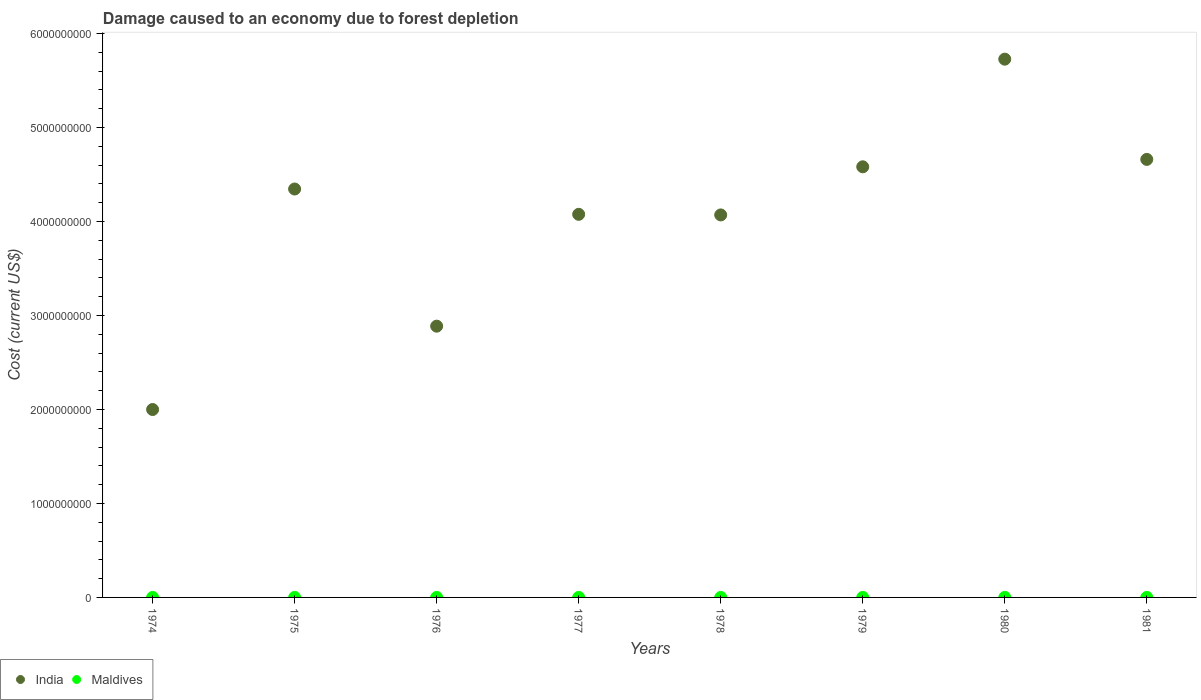How many different coloured dotlines are there?
Give a very brief answer. 2. Is the number of dotlines equal to the number of legend labels?
Provide a short and direct response. Yes. What is the cost of damage caused due to forest depletion in India in 1974?
Your response must be concise. 2.00e+09. Across all years, what is the maximum cost of damage caused due to forest depletion in India?
Your response must be concise. 5.73e+09. Across all years, what is the minimum cost of damage caused due to forest depletion in Maldives?
Provide a succinct answer. 7.74e+04. In which year was the cost of damage caused due to forest depletion in Maldives minimum?
Offer a very short reply. 1974. What is the total cost of damage caused due to forest depletion in India in the graph?
Keep it short and to the point. 3.23e+1. What is the difference between the cost of damage caused due to forest depletion in Maldives in 1974 and that in 1978?
Your response must be concise. -8.65e+04. What is the difference between the cost of damage caused due to forest depletion in India in 1979 and the cost of damage caused due to forest depletion in Maldives in 1980?
Your response must be concise. 4.58e+09. What is the average cost of damage caused due to forest depletion in Maldives per year?
Offer a very short reply. 1.62e+05. In the year 1980, what is the difference between the cost of damage caused due to forest depletion in Maldives and cost of damage caused due to forest depletion in India?
Provide a short and direct response. -5.73e+09. In how many years, is the cost of damage caused due to forest depletion in India greater than 4000000000 US$?
Make the answer very short. 6. What is the ratio of the cost of damage caused due to forest depletion in Maldives in 1975 to that in 1977?
Offer a terse response. 1.21. Is the difference between the cost of damage caused due to forest depletion in Maldives in 1977 and 1979 greater than the difference between the cost of damage caused due to forest depletion in India in 1977 and 1979?
Provide a succinct answer. Yes. What is the difference between the highest and the second highest cost of damage caused due to forest depletion in India?
Your answer should be compact. 1.07e+09. What is the difference between the highest and the lowest cost of damage caused due to forest depletion in Maldives?
Give a very brief answer. 1.46e+05. Is the sum of the cost of damage caused due to forest depletion in India in 1979 and 1980 greater than the maximum cost of damage caused due to forest depletion in Maldives across all years?
Offer a terse response. Yes. What is the difference between two consecutive major ticks on the Y-axis?
Provide a short and direct response. 1.00e+09. Are the values on the major ticks of Y-axis written in scientific E-notation?
Ensure brevity in your answer.  No. Does the graph contain any zero values?
Offer a very short reply. No. How many legend labels are there?
Make the answer very short. 2. How are the legend labels stacked?
Your answer should be compact. Horizontal. What is the title of the graph?
Give a very brief answer. Damage caused to an economy due to forest depletion. Does "Estonia" appear as one of the legend labels in the graph?
Your answer should be very brief. No. What is the label or title of the Y-axis?
Provide a short and direct response. Cost (current US$). What is the Cost (current US$) of India in 1974?
Ensure brevity in your answer.  2.00e+09. What is the Cost (current US$) in Maldives in 1974?
Provide a succinct answer. 7.74e+04. What is the Cost (current US$) of India in 1975?
Your answer should be very brief. 4.35e+09. What is the Cost (current US$) in Maldives in 1975?
Give a very brief answer. 1.96e+05. What is the Cost (current US$) in India in 1976?
Offer a very short reply. 2.89e+09. What is the Cost (current US$) of Maldives in 1976?
Provide a succinct answer. 1.11e+05. What is the Cost (current US$) of India in 1977?
Provide a succinct answer. 4.08e+09. What is the Cost (current US$) in Maldives in 1977?
Make the answer very short. 1.63e+05. What is the Cost (current US$) of India in 1978?
Ensure brevity in your answer.  4.07e+09. What is the Cost (current US$) of Maldives in 1978?
Ensure brevity in your answer.  1.64e+05. What is the Cost (current US$) in India in 1979?
Your answer should be very brief. 4.58e+09. What is the Cost (current US$) of Maldives in 1979?
Offer a very short reply. 1.77e+05. What is the Cost (current US$) in India in 1980?
Give a very brief answer. 5.73e+09. What is the Cost (current US$) in Maldives in 1980?
Give a very brief answer. 2.24e+05. What is the Cost (current US$) of India in 1981?
Provide a short and direct response. 4.66e+09. What is the Cost (current US$) in Maldives in 1981?
Offer a terse response. 1.82e+05. Across all years, what is the maximum Cost (current US$) of India?
Give a very brief answer. 5.73e+09. Across all years, what is the maximum Cost (current US$) of Maldives?
Offer a very short reply. 2.24e+05. Across all years, what is the minimum Cost (current US$) of India?
Your answer should be very brief. 2.00e+09. Across all years, what is the minimum Cost (current US$) of Maldives?
Give a very brief answer. 7.74e+04. What is the total Cost (current US$) in India in the graph?
Give a very brief answer. 3.23e+1. What is the total Cost (current US$) of Maldives in the graph?
Your response must be concise. 1.30e+06. What is the difference between the Cost (current US$) of India in 1974 and that in 1975?
Offer a terse response. -2.35e+09. What is the difference between the Cost (current US$) of Maldives in 1974 and that in 1975?
Give a very brief answer. -1.19e+05. What is the difference between the Cost (current US$) of India in 1974 and that in 1976?
Offer a very short reply. -8.87e+08. What is the difference between the Cost (current US$) in Maldives in 1974 and that in 1976?
Your answer should be compact. -3.35e+04. What is the difference between the Cost (current US$) of India in 1974 and that in 1977?
Offer a terse response. -2.08e+09. What is the difference between the Cost (current US$) of Maldives in 1974 and that in 1977?
Ensure brevity in your answer.  -8.54e+04. What is the difference between the Cost (current US$) in India in 1974 and that in 1978?
Provide a succinct answer. -2.07e+09. What is the difference between the Cost (current US$) of Maldives in 1974 and that in 1978?
Give a very brief answer. -8.65e+04. What is the difference between the Cost (current US$) of India in 1974 and that in 1979?
Your response must be concise. -2.58e+09. What is the difference between the Cost (current US$) of Maldives in 1974 and that in 1979?
Your response must be concise. -1.00e+05. What is the difference between the Cost (current US$) of India in 1974 and that in 1980?
Provide a succinct answer. -3.73e+09. What is the difference between the Cost (current US$) in Maldives in 1974 and that in 1980?
Offer a terse response. -1.46e+05. What is the difference between the Cost (current US$) in India in 1974 and that in 1981?
Give a very brief answer. -2.66e+09. What is the difference between the Cost (current US$) in Maldives in 1974 and that in 1981?
Your response must be concise. -1.05e+05. What is the difference between the Cost (current US$) in India in 1975 and that in 1976?
Your answer should be compact. 1.46e+09. What is the difference between the Cost (current US$) of Maldives in 1975 and that in 1976?
Provide a succinct answer. 8.53e+04. What is the difference between the Cost (current US$) of India in 1975 and that in 1977?
Ensure brevity in your answer.  2.69e+08. What is the difference between the Cost (current US$) of Maldives in 1975 and that in 1977?
Make the answer very short. 3.34e+04. What is the difference between the Cost (current US$) in India in 1975 and that in 1978?
Keep it short and to the point. 2.76e+08. What is the difference between the Cost (current US$) in Maldives in 1975 and that in 1978?
Make the answer very short. 3.24e+04. What is the difference between the Cost (current US$) of India in 1975 and that in 1979?
Your answer should be compact. -2.36e+08. What is the difference between the Cost (current US$) in Maldives in 1975 and that in 1979?
Make the answer very short. 1.88e+04. What is the difference between the Cost (current US$) of India in 1975 and that in 1980?
Offer a terse response. -1.38e+09. What is the difference between the Cost (current US$) in Maldives in 1975 and that in 1980?
Keep it short and to the point. -2.76e+04. What is the difference between the Cost (current US$) of India in 1975 and that in 1981?
Offer a terse response. -3.15e+08. What is the difference between the Cost (current US$) in Maldives in 1975 and that in 1981?
Ensure brevity in your answer.  1.38e+04. What is the difference between the Cost (current US$) of India in 1976 and that in 1977?
Keep it short and to the point. -1.19e+09. What is the difference between the Cost (current US$) in Maldives in 1976 and that in 1977?
Give a very brief answer. -5.19e+04. What is the difference between the Cost (current US$) of India in 1976 and that in 1978?
Provide a short and direct response. -1.18e+09. What is the difference between the Cost (current US$) in Maldives in 1976 and that in 1978?
Offer a very short reply. -5.29e+04. What is the difference between the Cost (current US$) of India in 1976 and that in 1979?
Your answer should be very brief. -1.70e+09. What is the difference between the Cost (current US$) in Maldives in 1976 and that in 1979?
Your response must be concise. -6.65e+04. What is the difference between the Cost (current US$) of India in 1976 and that in 1980?
Provide a succinct answer. -2.84e+09. What is the difference between the Cost (current US$) in Maldives in 1976 and that in 1980?
Make the answer very short. -1.13e+05. What is the difference between the Cost (current US$) in India in 1976 and that in 1981?
Your answer should be very brief. -1.77e+09. What is the difference between the Cost (current US$) of Maldives in 1976 and that in 1981?
Keep it short and to the point. -7.15e+04. What is the difference between the Cost (current US$) of India in 1977 and that in 1978?
Offer a very short reply. 6.45e+06. What is the difference between the Cost (current US$) in Maldives in 1977 and that in 1978?
Your answer should be compact. -1039.7. What is the difference between the Cost (current US$) of India in 1977 and that in 1979?
Your answer should be compact. -5.06e+08. What is the difference between the Cost (current US$) of Maldives in 1977 and that in 1979?
Offer a terse response. -1.46e+04. What is the difference between the Cost (current US$) in India in 1977 and that in 1980?
Offer a terse response. -1.65e+09. What is the difference between the Cost (current US$) in Maldives in 1977 and that in 1980?
Provide a succinct answer. -6.10e+04. What is the difference between the Cost (current US$) in India in 1977 and that in 1981?
Give a very brief answer. -5.84e+08. What is the difference between the Cost (current US$) in Maldives in 1977 and that in 1981?
Provide a short and direct response. -1.96e+04. What is the difference between the Cost (current US$) of India in 1978 and that in 1979?
Provide a succinct answer. -5.12e+08. What is the difference between the Cost (current US$) of Maldives in 1978 and that in 1979?
Your answer should be very brief. -1.36e+04. What is the difference between the Cost (current US$) in India in 1978 and that in 1980?
Offer a very short reply. -1.66e+09. What is the difference between the Cost (current US$) in Maldives in 1978 and that in 1980?
Offer a very short reply. -5.99e+04. What is the difference between the Cost (current US$) in India in 1978 and that in 1981?
Your response must be concise. -5.91e+08. What is the difference between the Cost (current US$) in Maldives in 1978 and that in 1981?
Your response must be concise. -1.85e+04. What is the difference between the Cost (current US$) in India in 1979 and that in 1980?
Ensure brevity in your answer.  -1.15e+09. What is the difference between the Cost (current US$) in Maldives in 1979 and that in 1980?
Provide a succinct answer. -4.63e+04. What is the difference between the Cost (current US$) in India in 1979 and that in 1981?
Your response must be concise. -7.88e+07. What is the difference between the Cost (current US$) of Maldives in 1979 and that in 1981?
Your answer should be compact. -4977.71. What is the difference between the Cost (current US$) in India in 1980 and that in 1981?
Ensure brevity in your answer.  1.07e+09. What is the difference between the Cost (current US$) of Maldives in 1980 and that in 1981?
Provide a succinct answer. 4.14e+04. What is the difference between the Cost (current US$) of India in 1974 and the Cost (current US$) of Maldives in 1975?
Offer a very short reply. 2.00e+09. What is the difference between the Cost (current US$) of India in 1974 and the Cost (current US$) of Maldives in 1976?
Your response must be concise. 2.00e+09. What is the difference between the Cost (current US$) in India in 1974 and the Cost (current US$) in Maldives in 1977?
Keep it short and to the point. 2.00e+09. What is the difference between the Cost (current US$) of India in 1974 and the Cost (current US$) of Maldives in 1978?
Keep it short and to the point. 2.00e+09. What is the difference between the Cost (current US$) of India in 1974 and the Cost (current US$) of Maldives in 1979?
Make the answer very short. 2.00e+09. What is the difference between the Cost (current US$) in India in 1974 and the Cost (current US$) in Maldives in 1980?
Keep it short and to the point. 2.00e+09. What is the difference between the Cost (current US$) in India in 1974 and the Cost (current US$) in Maldives in 1981?
Offer a very short reply. 2.00e+09. What is the difference between the Cost (current US$) in India in 1975 and the Cost (current US$) in Maldives in 1976?
Keep it short and to the point. 4.35e+09. What is the difference between the Cost (current US$) of India in 1975 and the Cost (current US$) of Maldives in 1977?
Offer a terse response. 4.35e+09. What is the difference between the Cost (current US$) in India in 1975 and the Cost (current US$) in Maldives in 1978?
Provide a short and direct response. 4.35e+09. What is the difference between the Cost (current US$) in India in 1975 and the Cost (current US$) in Maldives in 1979?
Your answer should be very brief. 4.35e+09. What is the difference between the Cost (current US$) in India in 1975 and the Cost (current US$) in Maldives in 1980?
Keep it short and to the point. 4.35e+09. What is the difference between the Cost (current US$) in India in 1975 and the Cost (current US$) in Maldives in 1981?
Your answer should be compact. 4.35e+09. What is the difference between the Cost (current US$) of India in 1976 and the Cost (current US$) of Maldives in 1977?
Make the answer very short. 2.89e+09. What is the difference between the Cost (current US$) in India in 1976 and the Cost (current US$) in Maldives in 1978?
Your answer should be compact. 2.89e+09. What is the difference between the Cost (current US$) in India in 1976 and the Cost (current US$) in Maldives in 1979?
Your answer should be very brief. 2.89e+09. What is the difference between the Cost (current US$) in India in 1976 and the Cost (current US$) in Maldives in 1980?
Your response must be concise. 2.89e+09. What is the difference between the Cost (current US$) of India in 1976 and the Cost (current US$) of Maldives in 1981?
Keep it short and to the point. 2.89e+09. What is the difference between the Cost (current US$) in India in 1977 and the Cost (current US$) in Maldives in 1978?
Offer a very short reply. 4.08e+09. What is the difference between the Cost (current US$) in India in 1977 and the Cost (current US$) in Maldives in 1979?
Your answer should be very brief. 4.08e+09. What is the difference between the Cost (current US$) of India in 1977 and the Cost (current US$) of Maldives in 1980?
Ensure brevity in your answer.  4.08e+09. What is the difference between the Cost (current US$) in India in 1977 and the Cost (current US$) in Maldives in 1981?
Ensure brevity in your answer.  4.08e+09. What is the difference between the Cost (current US$) of India in 1978 and the Cost (current US$) of Maldives in 1979?
Provide a short and direct response. 4.07e+09. What is the difference between the Cost (current US$) in India in 1978 and the Cost (current US$) in Maldives in 1980?
Your answer should be compact. 4.07e+09. What is the difference between the Cost (current US$) in India in 1978 and the Cost (current US$) in Maldives in 1981?
Provide a short and direct response. 4.07e+09. What is the difference between the Cost (current US$) of India in 1979 and the Cost (current US$) of Maldives in 1980?
Offer a terse response. 4.58e+09. What is the difference between the Cost (current US$) in India in 1979 and the Cost (current US$) in Maldives in 1981?
Offer a very short reply. 4.58e+09. What is the difference between the Cost (current US$) of India in 1980 and the Cost (current US$) of Maldives in 1981?
Offer a terse response. 5.73e+09. What is the average Cost (current US$) in India per year?
Give a very brief answer. 4.04e+09. What is the average Cost (current US$) in Maldives per year?
Give a very brief answer. 1.62e+05. In the year 1974, what is the difference between the Cost (current US$) in India and Cost (current US$) in Maldives?
Keep it short and to the point. 2.00e+09. In the year 1975, what is the difference between the Cost (current US$) in India and Cost (current US$) in Maldives?
Keep it short and to the point. 4.35e+09. In the year 1976, what is the difference between the Cost (current US$) of India and Cost (current US$) of Maldives?
Provide a succinct answer. 2.89e+09. In the year 1977, what is the difference between the Cost (current US$) of India and Cost (current US$) of Maldives?
Your response must be concise. 4.08e+09. In the year 1978, what is the difference between the Cost (current US$) in India and Cost (current US$) in Maldives?
Ensure brevity in your answer.  4.07e+09. In the year 1979, what is the difference between the Cost (current US$) in India and Cost (current US$) in Maldives?
Keep it short and to the point. 4.58e+09. In the year 1980, what is the difference between the Cost (current US$) in India and Cost (current US$) in Maldives?
Offer a terse response. 5.73e+09. In the year 1981, what is the difference between the Cost (current US$) in India and Cost (current US$) in Maldives?
Make the answer very short. 4.66e+09. What is the ratio of the Cost (current US$) of India in 1974 to that in 1975?
Ensure brevity in your answer.  0.46. What is the ratio of the Cost (current US$) of Maldives in 1974 to that in 1975?
Offer a terse response. 0.39. What is the ratio of the Cost (current US$) in India in 1974 to that in 1976?
Give a very brief answer. 0.69. What is the ratio of the Cost (current US$) of Maldives in 1974 to that in 1976?
Your answer should be compact. 0.7. What is the ratio of the Cost (current US$) of India in 1974 to that in 1977?
Ensure brevity in your answer.  0.49. What is the ratio of the Cost (current US$) in Maldives in 1974 to that in 1977?
Your response must be concise. 0.48. What is the ratio of the Cost (current US$) in India in 1974 to that in 1978?
Provide a short and direct response. 0.49. What is the ratio of the Cost (current US$) of Maldives in 1974 to that in 1978?
Provide a short and direct response. 0.47. What is the ratio of the Cost (current US$) in India in 1974 to that in 1979?
Provide a short and direct response. 0.44. What is the ratio of the Cost (current US$) in Maldives in 1974 to that in 1979?
Offer a very short reply. 0.44. What is the ratio of the Cost (current US$) of India in 1974 to that in 1980?
Your answer should be compact. 0.35. What is the ratio of the Cost (current US$) of Maldives in 1974 to that in 1980?
Offer a very short reply. 0.35. What is the ratio of the Cost (current US$) in India in 1974 to that in 1981?
Offer a very short reply. 0.43. What is the ratio of the Cost (current US$) of Maldives in 1974 to that in 1981?
Give a very brief answer. 0.42. What is the ratio of the Cost (current US$) in India in 1975 to that in 1976?
Provide a short and direct response. 1.51. What is the ratio of the Cost (current US$) of Maldives in 1975 to that in 1976?
Provide a succinct answer. 1.77. What is the ratio of the Cost (current US$) of India in 1975 to that in 1977?
Your answer should be compact. 1.07. What is the ratio of the Cost (current US$) in Maldives in 1975 to that in 1977?
Your answer should be very brief. 1.21. What is the ratio of the Cost (current US$) in India in 1975 to that in 1978?
Your answer should be compact. 1.07. What is the ratio of the Cost (current US$) of Maldives in 1975 to that in 1978?
Give a very brief answer. 1.2. What is the ratio of the Cost (current US$) in India in 1975 to that in 1979?
Provide a succinct answer. 0.95. What is the ratio of the Cost (current US$) of Maldives in 1975 to that in 1979?
Give a very brief answer. 1.11. What is the ratio of the Cost (current US$) in India in 1975 to that in 1980?
Your answer should be very brief. 0.76. What is the ratio of the Cost (current US$) of Maldives in 1975 to that in 1980?
Provide a short and direct response. 0.88. What is the ratio of the Cost (current US$) in India in 1975 to that in 1981?
Ensure brevity in your answer.  0.93. What is the ratio of the Cost (current US$) in Maldives in 1975 to that in 1981?
Make the answer very short. 1.08. What is the ratio of the Cost (current US$) of India in 1976 to that in 1977?
Provide a succinct answer. 0.71. What is the ratio of the Cost (current US$) of Maldives in 1976 to that in 1977?
Your response must be concise. 0.68. What is the ratio of the Cost (current US$) of India in 1976 to that in 1978?
Your response must be concise. 0.71. What is the ratio of the Cost (current US$) in Maldives in 1976 to that in 1978?
Keep it short and to the point. 0.68. What is the ratio of the Cost (current US$) in India in 1976 to that in 1979?
Ensure brevity in your answer.  0.63. What is the ratio of the Cost (current US$) of Maldives in 1976 to that in 1979?
Your answer should be very brief. 0.63. What is the ratio of the Cost (current US$) of India in 1976 to that in 1980?
Give a very brief answer. 0.5. What is the ratio of the Cost (current US$) in Maldives in 1976 to that in 1980?
Offer a terse response. 0.5. What is the ratio of the Cost (current US$) in India in 1976 to that in 1981?
Your response must be concise. 0.62. What is the ratio of the Cost (current US$) of Maldives in 1976 to that in 1981?
Provide a succinct answer. 0.61. What is the ratio of the Cost (current US$) of India in 1977 to that in 1979?
Ensure brevity in your answer.  0.89. What is the ratio of the Cost (current US$) in Maldives in 1977 to that in 1979?
Provide a short and direct response. 0.92. What is the ratio of the Cost (current US$) of India in 1977 to that in 1980?
Your response must be concise. 0.71. What is the ratio of the Cost (current US$) of Maldives in 1977 to that in 1980?
Make the answer very short. 0.73. What is the ratio of the Cost (current US$) in India in 1977 to that in 1981?
Your answer should be compact. 0.87. What is the ratio of the Cost (current US$) of Maldives in 1977 to that in 1981?
Your answer should be very brief. 0.89. What is the ratio of the Cost (current US$) of India in 1978 to that in 1979?
Your response must be concise. 0.89. What is the ratio of the Cost (current US$) of Maldives in 1978 to that in 1979?
Ensure brevity in your answer.  0.92. What is the ratio of the Cost (current US$) in India in 1978 to that in 1980?
Your answer should be compact. 0.71. What is the ratio of the Cost (current US$) of Maldives in 1978 to that in 1980?
Offer a very short reply. 0.73. What is the ratio of the Cost (current US$) in India in 1978 to that in 1981?
Give a very brief answer. 0.87. What is the ratio of the Cost (current US$) of Maldives in 1978 to that in 1981?
Ensure brevity in your answer.  0.9. What is the ratio of the Cost (current US$) in Maldives in 1979 to that in 1980?
Your answer should be very brief. 0.79. What is the ratio of the Cost (current US$) of India in 1979 to that in 1981?
Ensure brevity in your answer.  0.98. What is the ratio of the Cost (current US$) of Maldives in 1979 to that in 1981?
Provide a succinct answer. 0.97. What is the ratio of the Cost (current US$) in India in 1980 to that in 1981?
Your answer should be very brief. 1.23. What is the ratio of the Cost (current US$) in Maldives in 1980 to that in 1981?
Give a very brief answer. 1.23. What is the difference between the highest and the second highest Cost (current US$) in India?
Your response must be concise. 1.07e+09. What is the difference between the highest and the second highest Cost (current US$) of Maldives?
Your answer should be very brief. 2.76e+04. What is the difference between the highest and the lowest Cost (current US$) in India?
Offer a very short reply. 3.73e+09. What is the difference between the highest and the lowest Cost (current US$) in Maldives?
Make the answer very short. 1.46e+05. 